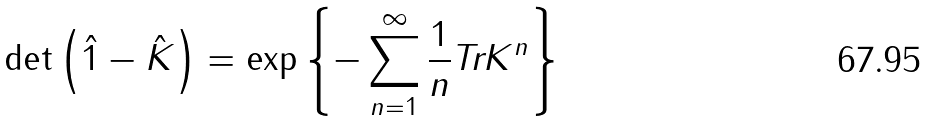<formula> <loc_0><loc_0><loc_500><loc_500>\det \left ( \hat { 1 } - \hat { K } \right ) = \exp \left \{ - \sum _ { n = 1 } ^ { \infty } \frac { 1 } { n } \text {Tr} K ^ { n } \right \}</formula> 